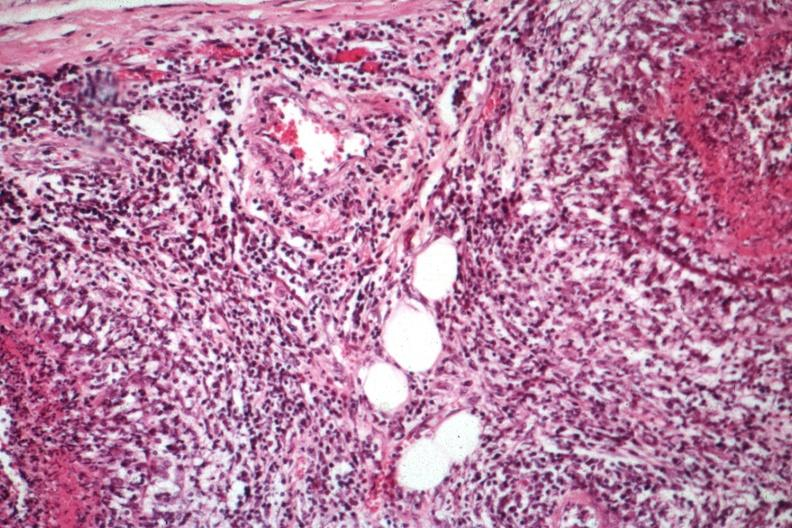s testicle present?
Answer the question using a single word or phrase. Yes 